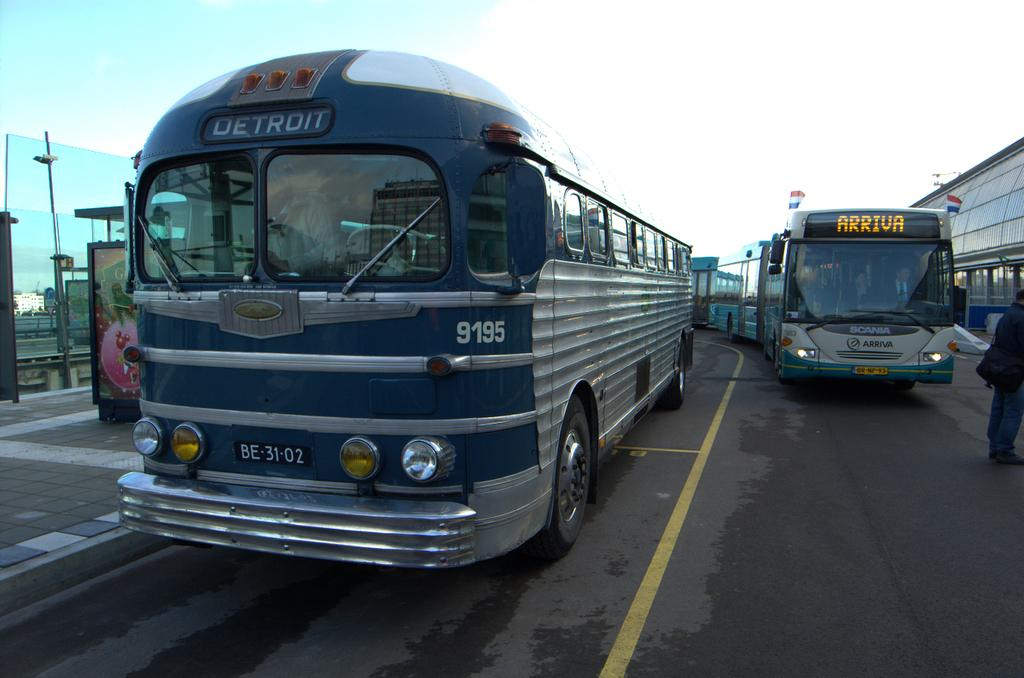Where was the image taken? The image was taken on a road. What can be seen on the road in the image? There are many buses parked on the road. What part of the image shows the road? The road is visible at the bottom of the image. What is present to the left of the image? There is a pavement to the left of the image. Can you describe the person in the image? There is a man standing to the right of the image. What type of memory does the man have in his hand in the image? There is no memory or any object resembling a memory in the man's hand in the image. What emotion does the man display in the image? The image does not convey any specific emotion, such as disgust or alarm, as it is a still photograph. 